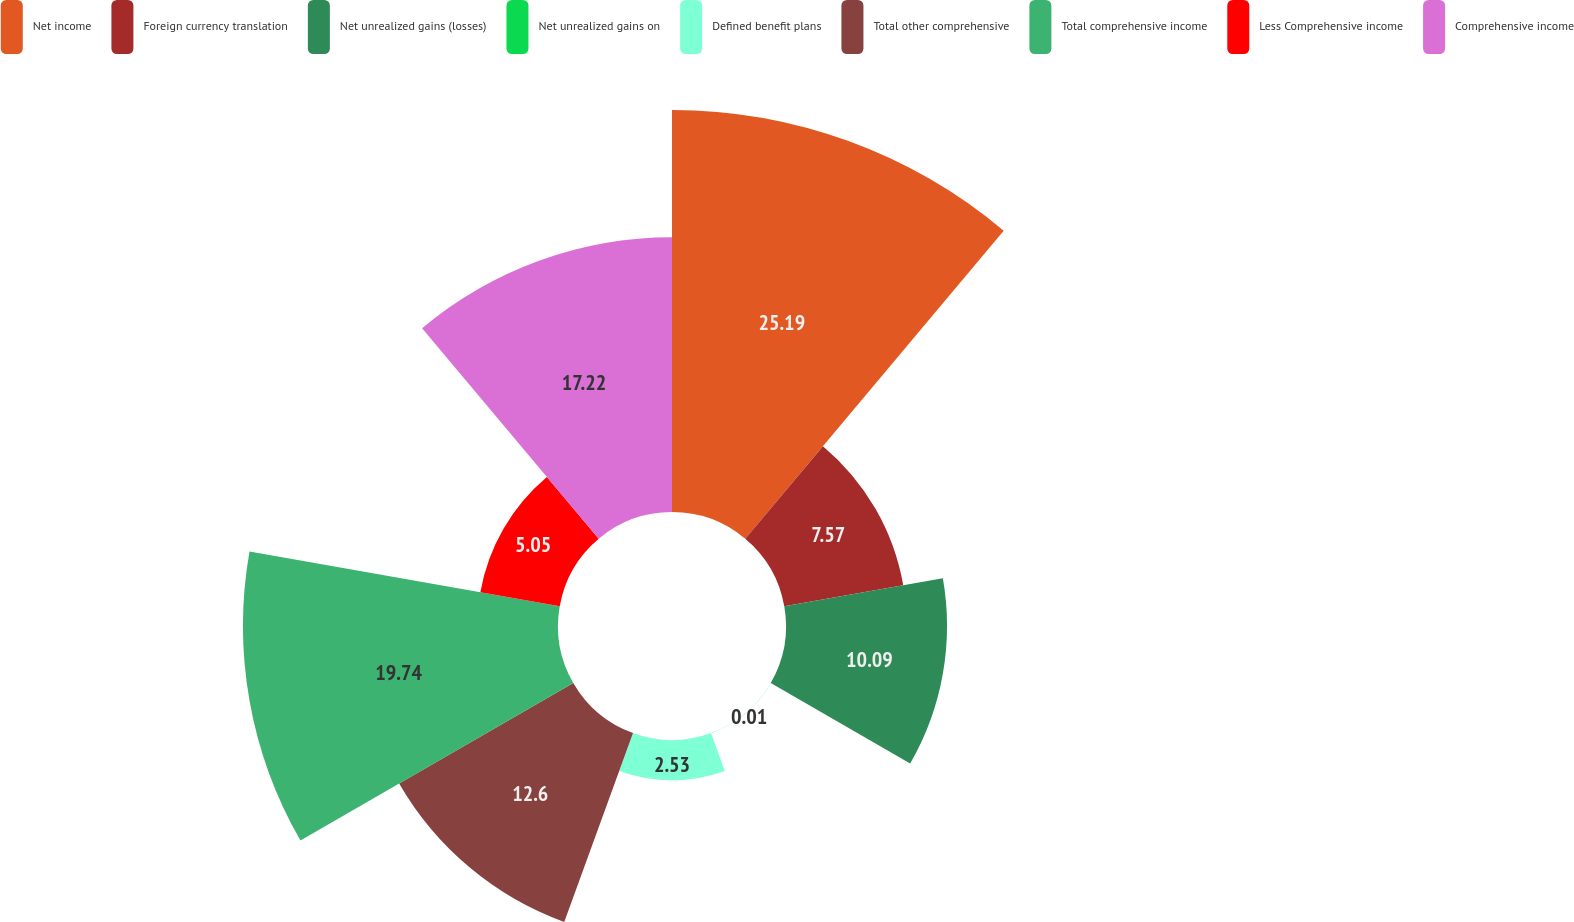Convert chart. <chart><loc_0><loc_0><loc_500><loc_500><pie_chart><fcel>Net income<fcel>Foreign currency translation<fcel>Net unrealized gains (losses)<fcel>Net unrealized gains on<fcel>Defined benefit plans<fcel>Total other comprehensive<fcel>Total comprehensive income<fcel>Less Comprehensive income<fcel>Comprehensive income<nl><fcel>25.19%<fcel>7.57%<fcel>10.09%<fcel>0.01%<fcel>2.53%<fcel>12.6%<fcel>19.74%<fcel>5.05%<fcel>17.22%<nl></chart> 